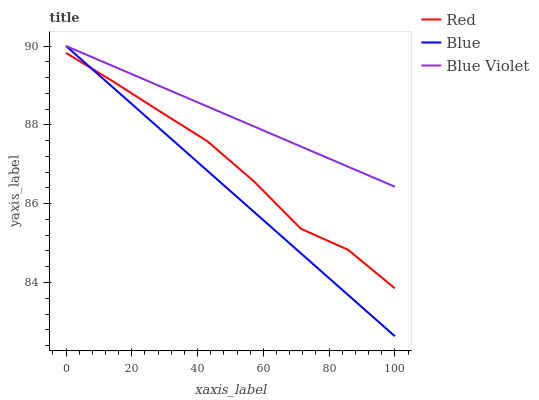Does Blue have the minimum area under the curve?
Answer yes or no. Yes. Does Blue Violet have the maximum area under the curve?
Answer yes or no. Yes. Does Red have the minimum area under the curve?
Answer yes or no. No. Does Red have the maximum area under the curve?
Answer yes or no. No. Is Blue Violet the smoothest?
Answer yes or no. Yes. Is Red the roughest?
Answer yes or no. Yes. Is Red the smoothest?
Answer yes or no. No. Is Blue Violet the roughest?
Answer yes or no. No. Does Red have the lowest value?
Answer yes or no. No. Does Blue Violet have the highest value?
Answer yes or no. Yes. Does Red have the highest value?
Answer yes or no. No. Is Red less than Blue Violet?
Answer yes or no. Yes. Is Blue Violet greater than Red?
Answer yes or no. Yes. Does Blue Violet intersect Blue?
Answer yes or no. Yes. Is Blue Violet less than Blue?
Answer yes or no. No. Is Blue Violet greater than Blue?
Answer yes or no. No. Does Red intersect Blue Violet?
Answer yes or no. No. 